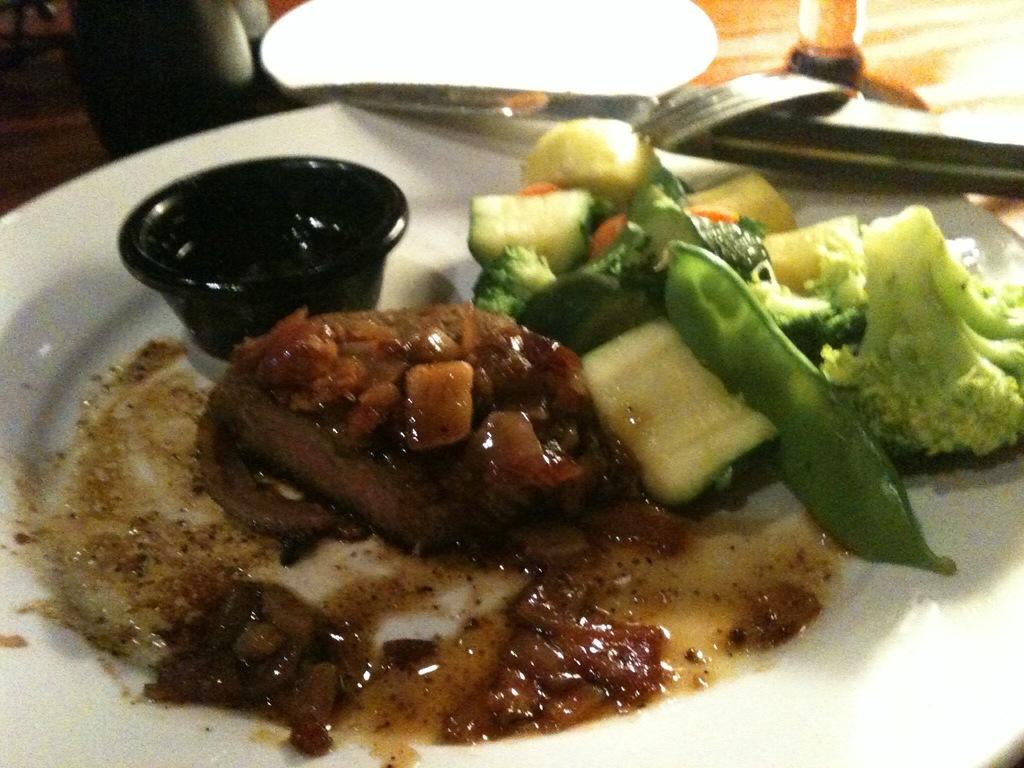What is on the plate that is visible in the image? The plate contains food items. What other dish is present in the image? There is a bowl in the image. What utensils can be seen in the image? There is a knife and a fork in the image. What is visible in the background of the image? There is a table and additional objects in the background of the image. What type of government is depicted in the image? There is no depiction of a government in the image; it features a plate, a bowl, utensils, and a table. What religious belief is represented by the objects in the image? There is no religious belief represented by the objects in the image; it simply shows a plate, a bowl, utensils, and a table. 